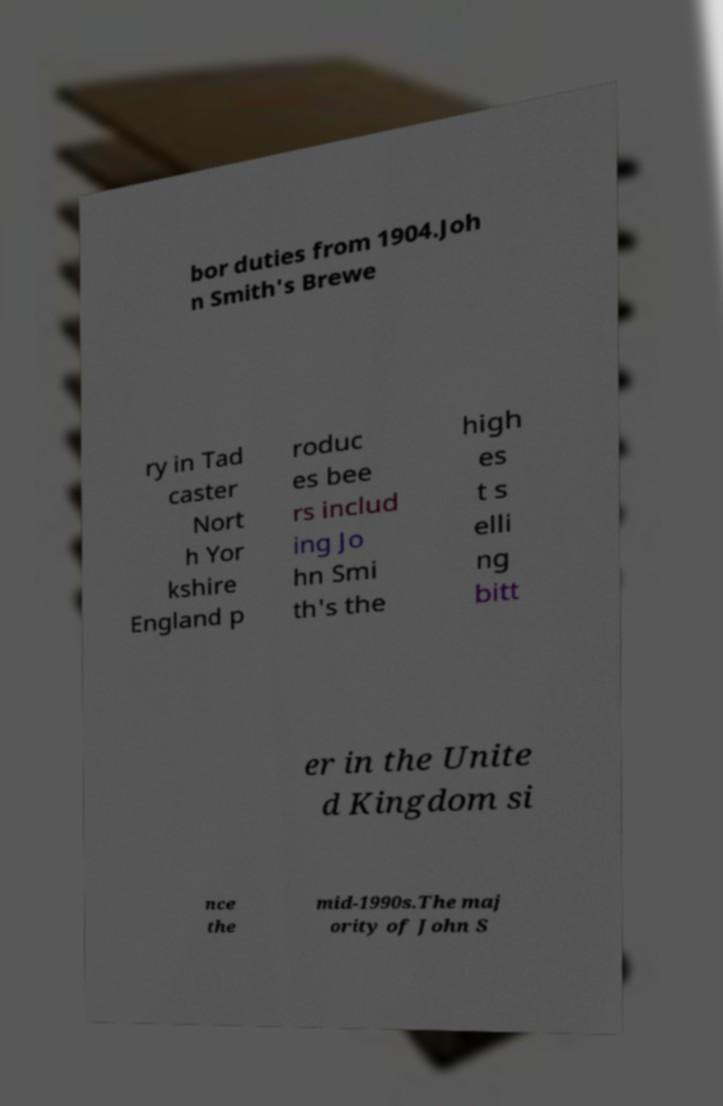Could you extract and type out the text from this image? bor duties from 1904.Joh n Smith's Brewe ry in Tad caster Nort h Yor kshire England p roduc es bee rs includ ing Jo hn Smi th's the high es t s elli ng bitt er in the Unite d Kingdom si nce the mid-1990s.The maj ority of John S 